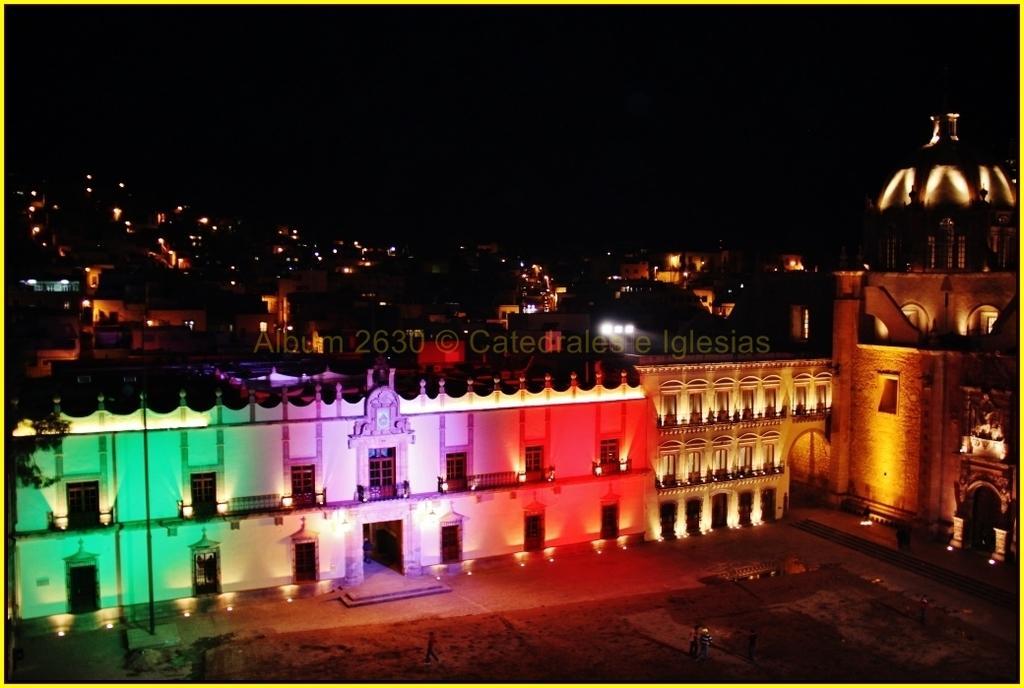Can you describe this image briefly? This is the picture of a night view and we can see some buildings and there are some different colors of lights. We can see a few people on the ground and among them one person is walking and we can see a tree. 